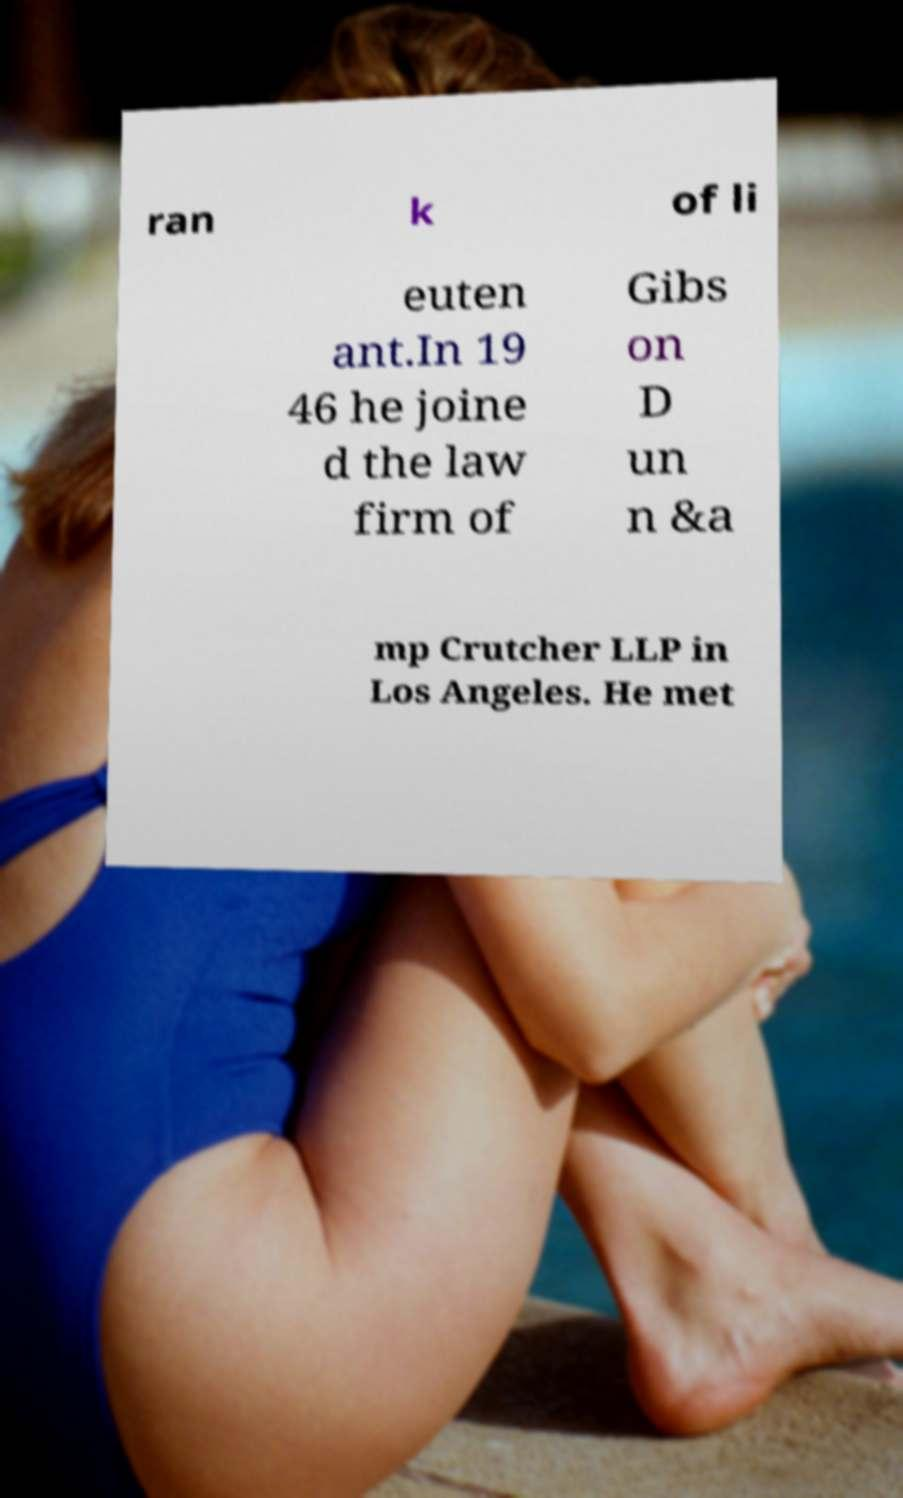Can you accurately transcribe the text from the provided image for me? ran k of li euten ant.In 19 46 he joine d the law firm of Gibs on D un n &a mp Crutcher LLP in Los Angeles. He met 